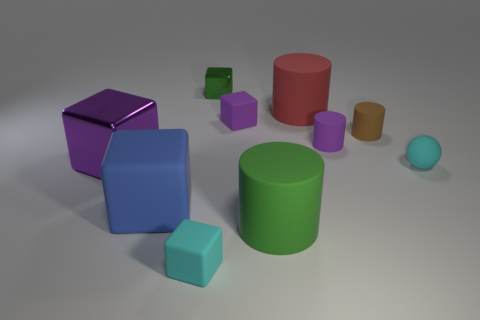Is the shape of the big blue thing the same as the big red rubber thing on the left side of the sphere?
Make the answer very short. No. How big is the thing that is both right of the purple rubber block and on the left side of the red rubber object?
Ensure brevity in your answer.  Large. How many purple cubes are there?
Your response must be concise. 2. There is a cylinder that is the same size as the brown thing; what is its material?
Offer a terse response. Rubber. Is there a rubber thing that has the same size as the purple shiny block?
Make the answer very short. Yes. There is a tiny rubber cube behind the big purple metallic cube; does it have the same color as the metallic thing that is in front of the brown cylinder?
Give a very brief answer. Yes. What number of matte objects are cylinders or big green cylinders?
Provide a succinct answer. 4. What number of large red matte cylinders are on the left side of the metal cube behind the small cylinder that is in front of the brown matte thing?
Provide a short and direct response. 0. What size is the green thing that is made of the same material as the brown object?
Offer a very short reply. Large. How many tiny blocks have the same color as the sphere?
Offer a terse response. 1. 